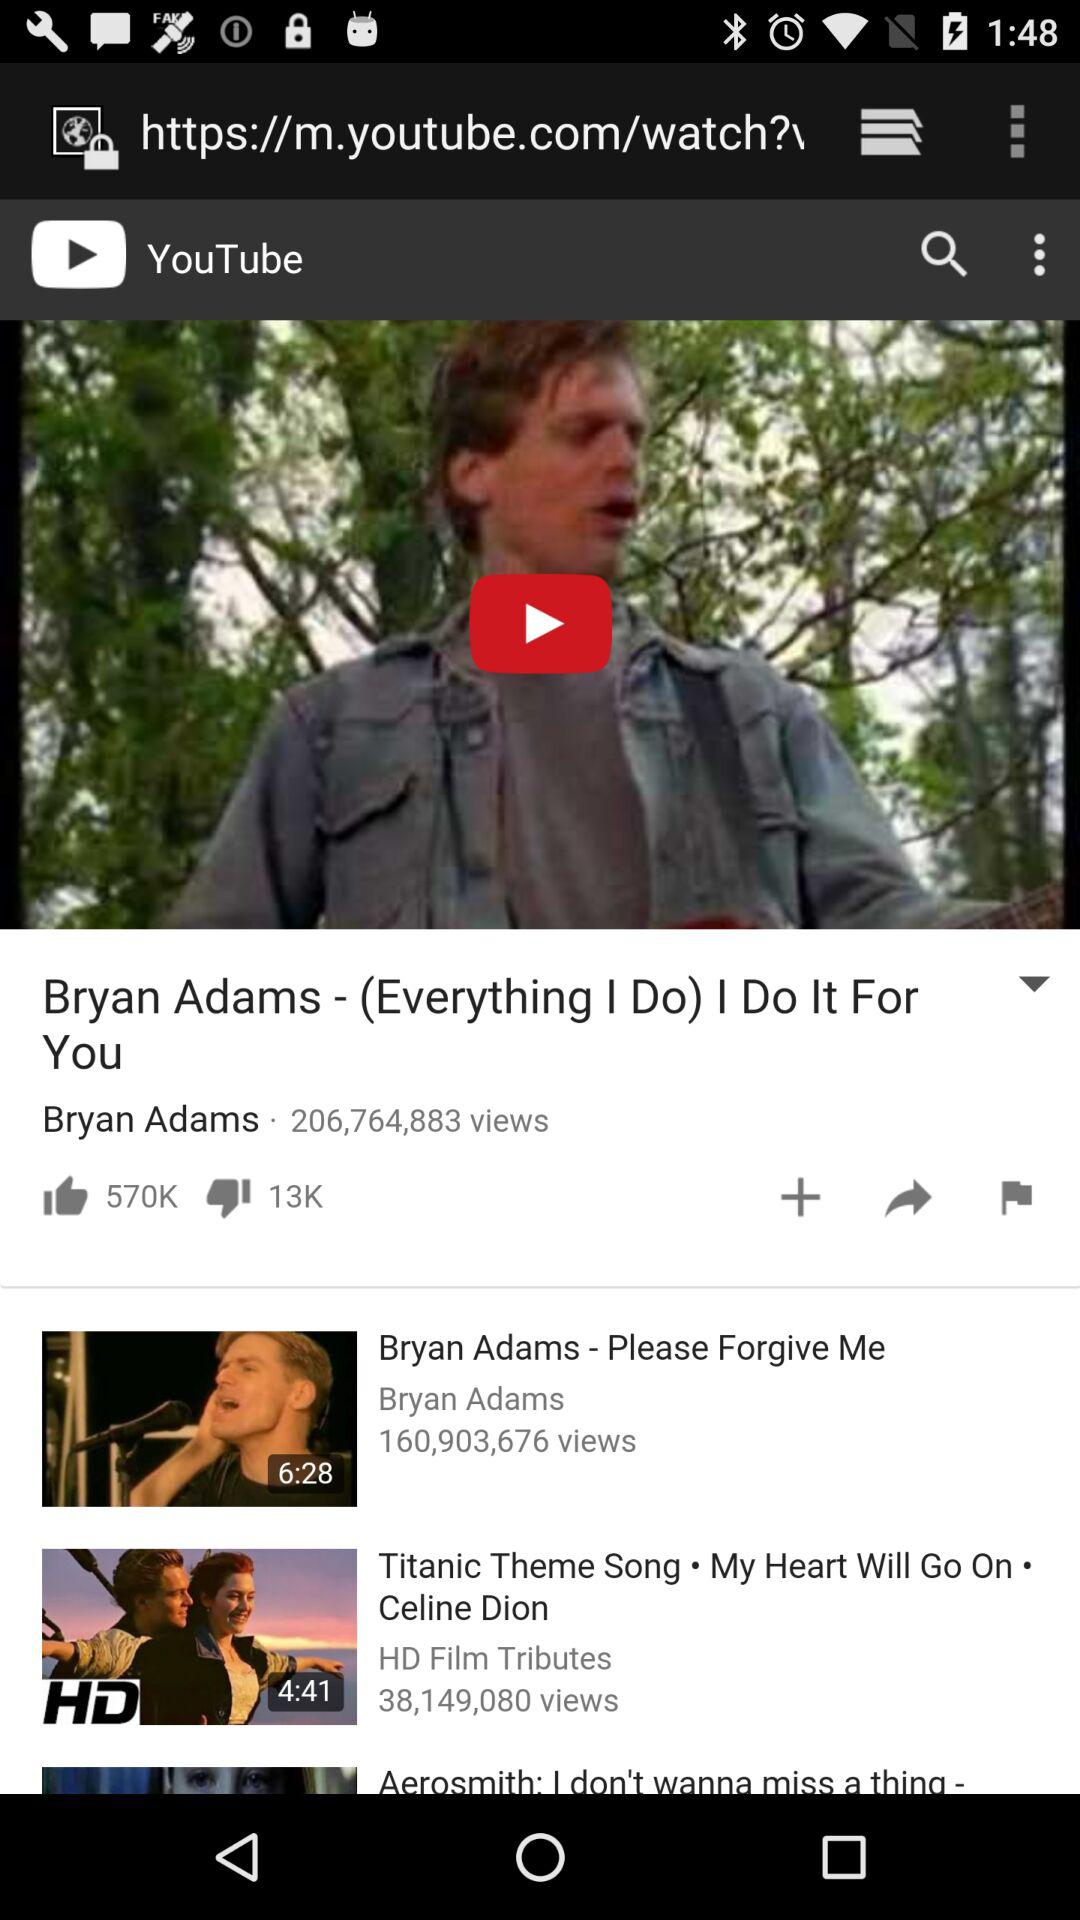What is the duration of "Titanic Theme Song"? The duration of "Titanic Theme Song" is 4 minutes and 41 seconds. 